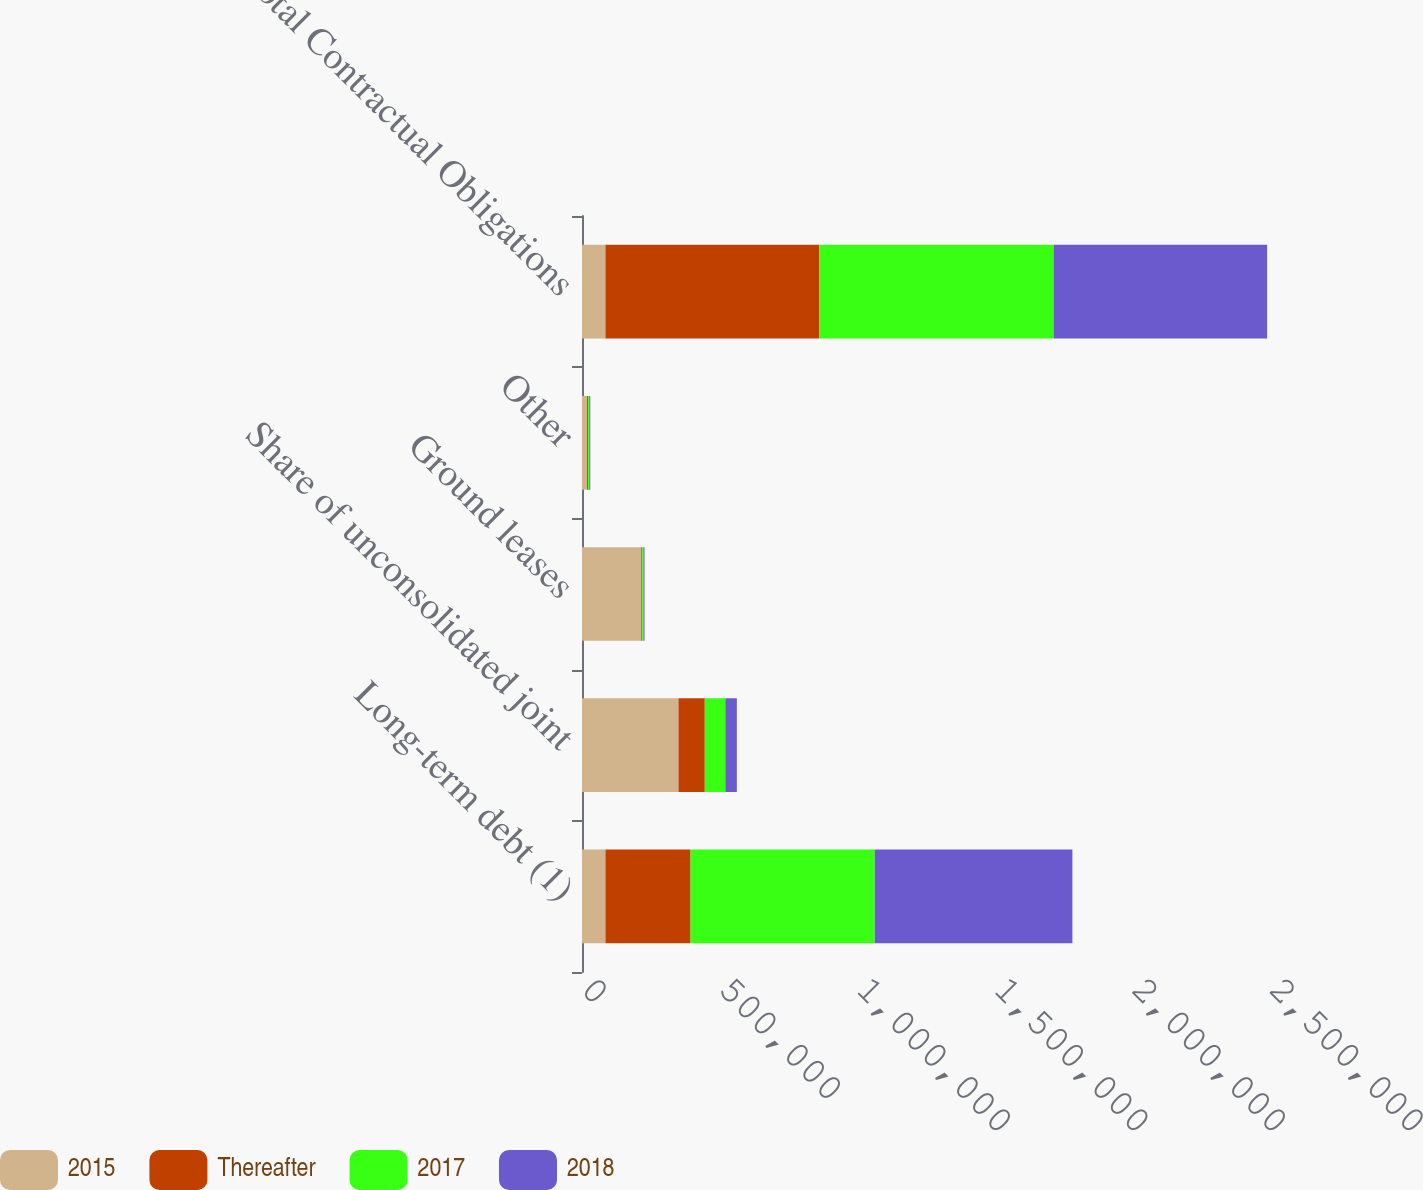<chart> <loc_0><loc_0><loc_500><loc_500><stacked_bar_chart><ecel><fcel>Long-term debt (1)<fcel>Share of unconsolidated joint<fcel>Ground leases<fcel>Other<fcel>Total Contractual Obligations<nl><fcel>2015<fcel>85137.5<fcel>350542<fcel>215406<fcel>18482<fcel>85137.5<nl><fcel>Thereafter<fcel>309325<fcel>95602<fcel>3816<fcel>3893<fcel>777589<nl><fcel>2017<fcel>669184<fcel>74673<fcel>3964<fcel>3936<fcel>850937<nl><fcel>2018<fcel>718319<fcel>41848<fcel>4010<fcel>3711<fcel>775826<nl></chart> 